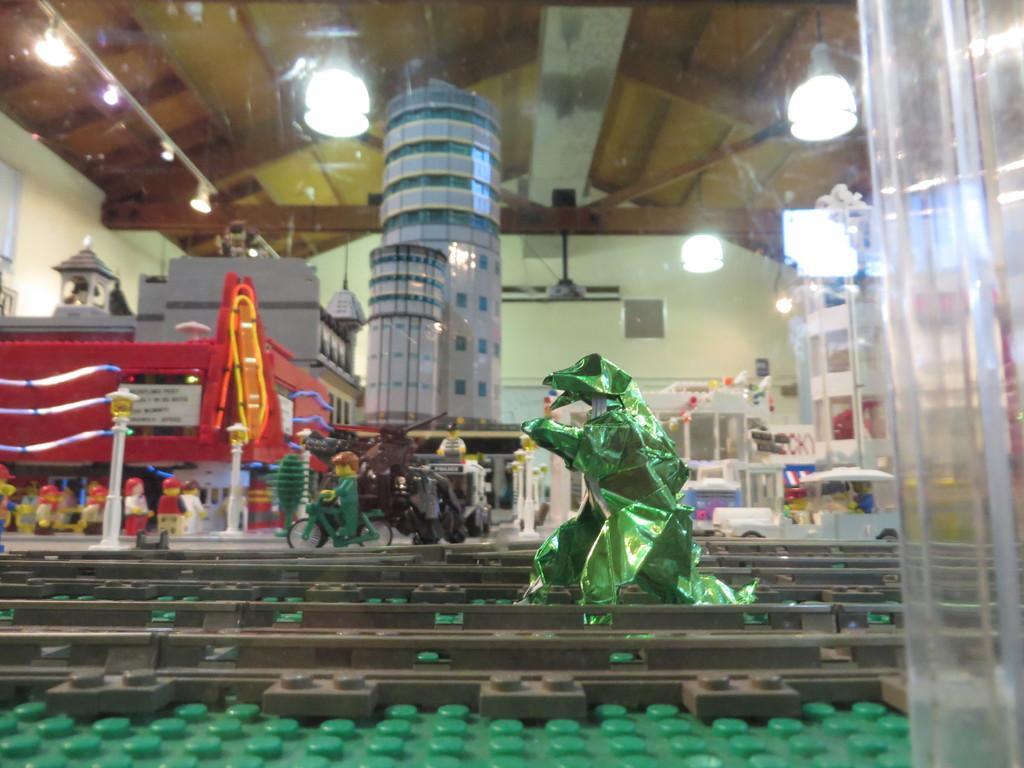How would you summarize this image in a sentence or two? In the middle of the picture, we see a toy in green color. At the bottom, we see the game pieces in grey and green color. Beside that, we see the toy vehicles and the dolls. In the background, we see a building. In the background, we see a wall. At the top, we see the lights and the ceiling of the room. 